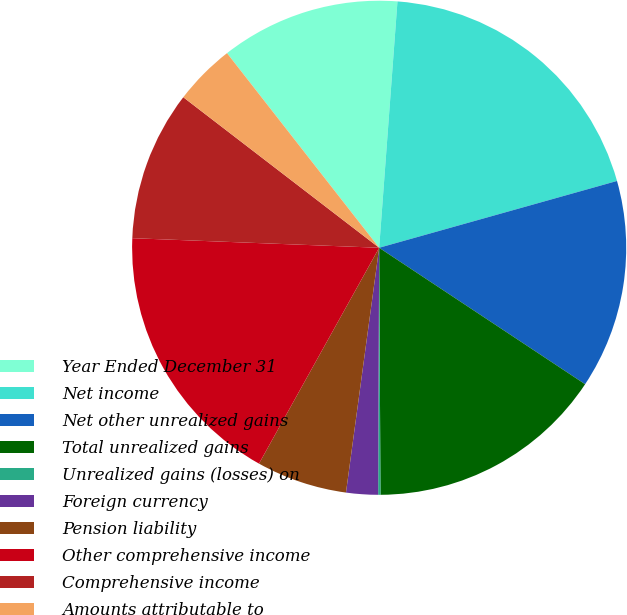Convert chart to OTSL. <chart><loc_0><loc_0><loc_500><loc_500><pie_chart><fcel>Year Ended December 31<fcel>Net income<fcel>Net other unrealized gains<fcel>Total unrealized gains<fcel>Unrealized gains (losses) on<fcel>Foreign currency<fcel>Pension liability<fcel>Other comprehensive income<fcel>Comprehensive income<fcel>Amounts attributable to<nl><fcel>11.74%<fcel>19.46%<fcel>13.67%<fcel>15.6%<fcel>0.15%<fcel>2.08%<fcel>5.94%<fcel>17.53%<fcel>9.81%<fcel>4.01%<nl></chart> 